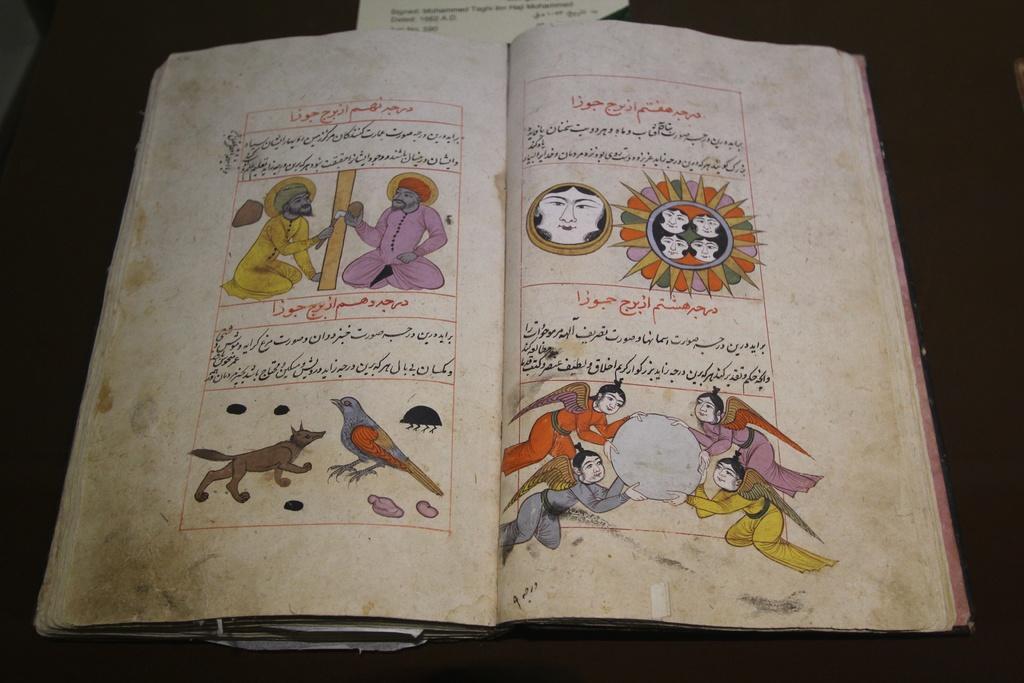How would you summarize this image in a sentence or two? There is an open book which has figures of people and animals. 